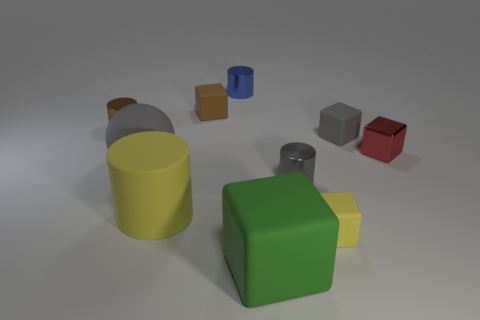Subtract 1 blocks. How many blocks are left? 4 Subtract all yellow cubes. How many cubes are left? 4 Subtract all red blocks. How many blocks are left? 4 Subtract all red cubes. Subtract all cyan spheres. How many cubes are left? 4 Subtract all balls. How many objects are left? 9 Add 1 tiny gray rubber objects. How many tiny gray rubber objects exist? 2 Subtract 1 yellow blocks. How many objects are left? 9 Subtract all large yellow cylinders. Subtract all tiny blue things. How many objects are left? 8 Add 5 gray matte spheres. How many gray matte spheres are left? 6 